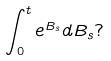<formula> <loc_0><loc_0><loc_500><loc_500>\int _ { 0 } ^ { t } e ^ { B _ { s } } d B _ { s } ?</formula> 